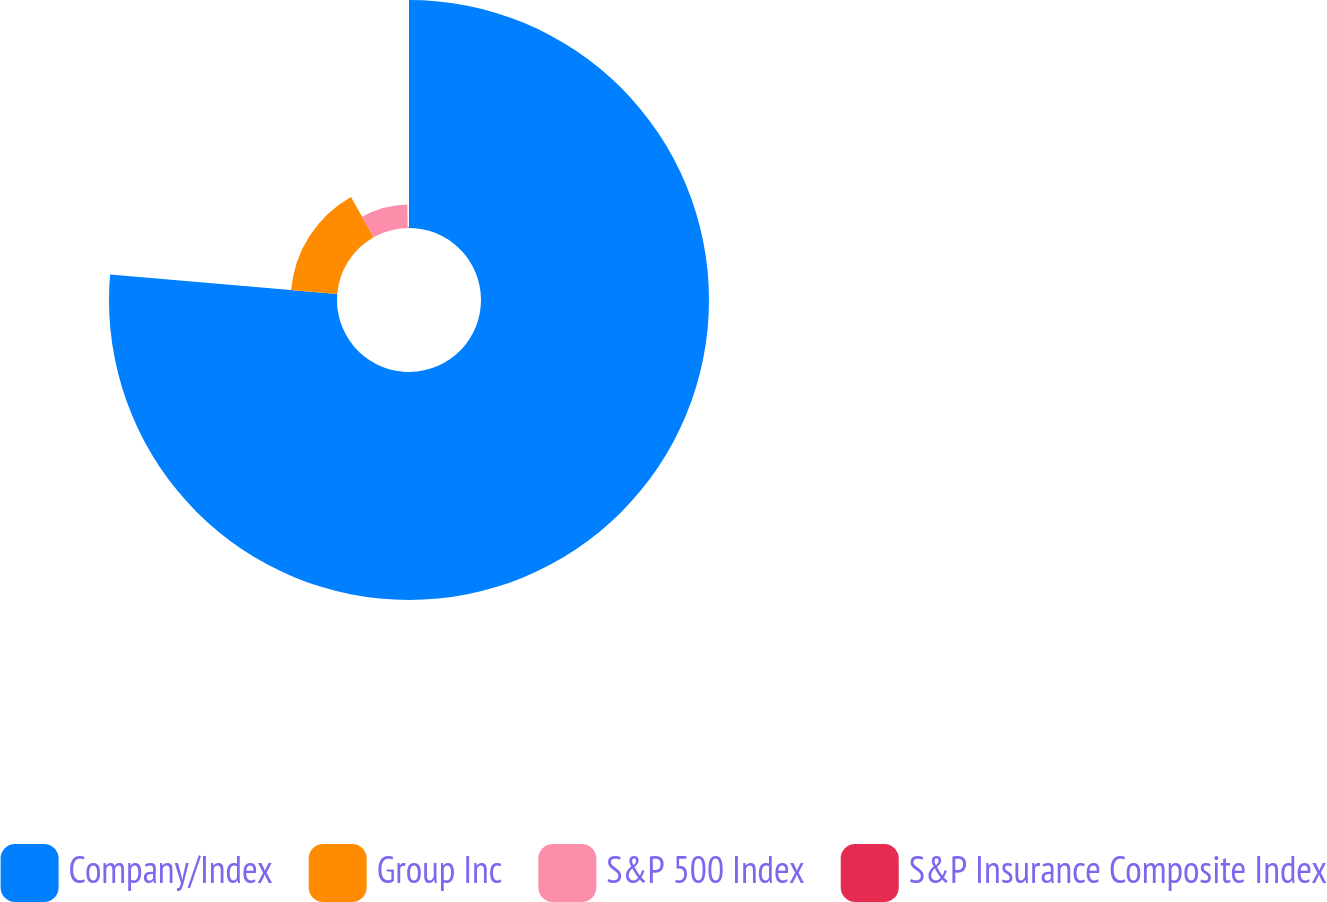Convert chart. <chart><loc_0><loc_0><loc_500><loc_500><pie_chart><fcel>Company/Index<fcel>Group Inc<fcel>S&P 500 Index<fcel>S&P Insurance Composite Index<nl><fcel>76.35%<fcel>15.49%<fcel>7.88%<fcel>0.28%<nl></chart> 